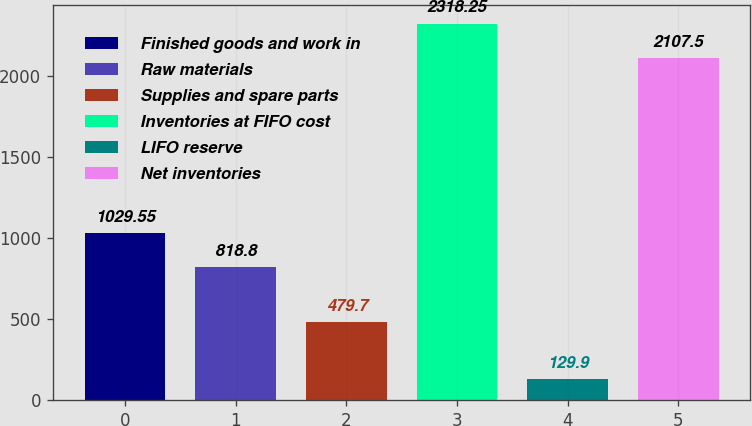Convert chart. <chart><loc_0><loc_0><loc_500><loc_500><bar_chart><fcel>Finished goods and work in<fcel>Raw materials<fcel>Supplies and spare parts<fcel>Inventories at FIFO cost<fcel>LIFO reserve<fcel>Net inventories<nl><fcel>1029.55<fcel>818.8<fcel>479.7<fcel>2318.25<fcel>129.9<fcel>2107.5<nl></chart> 